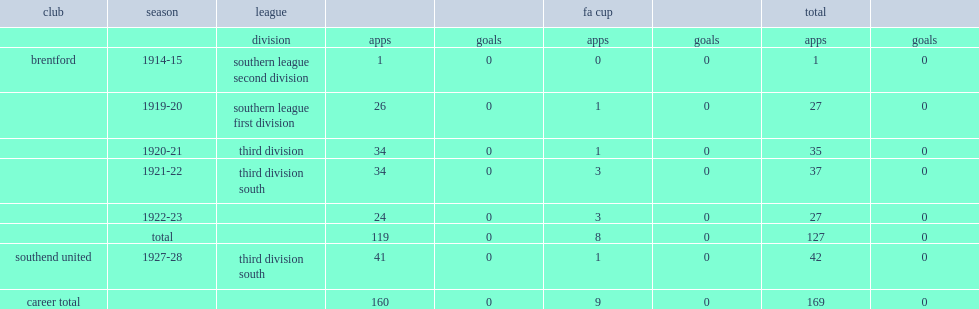What was the number of appearances made by rosier by 1923? 127.0. 